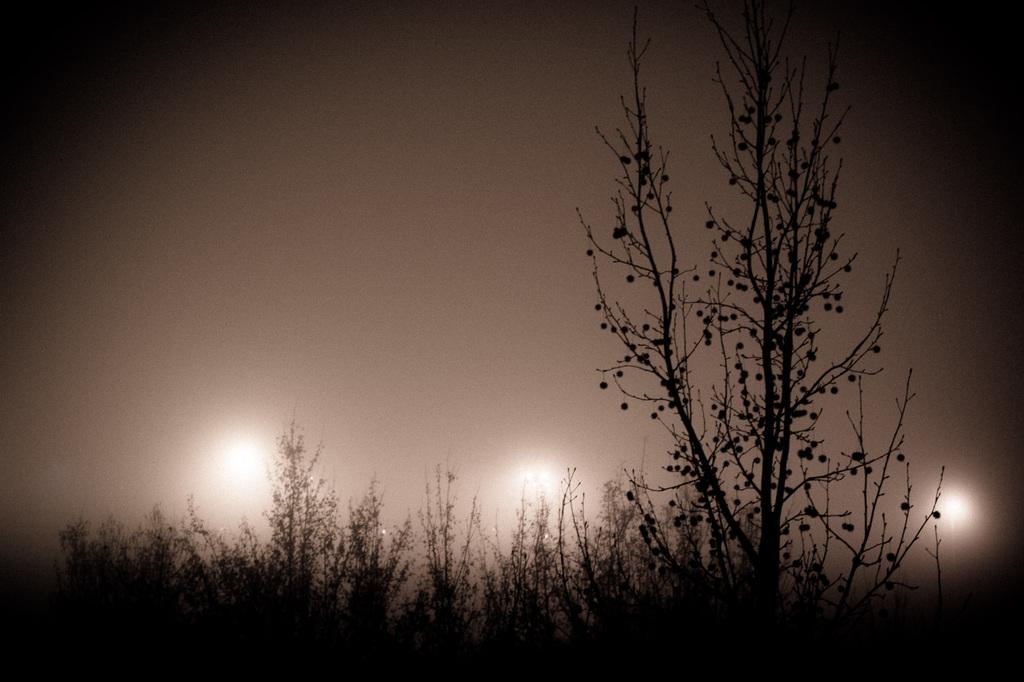What type of vegetation can be seen in the image? There are plants and trees in the image. Are there any artificial light sources visible in the image? Yes, there are lights in the image. What part of the natural environment is visible in the image? The sky is visible in the image. What type of hole can be seen in the image? There is no hole present in the image. Can you see any arms or guns in the image? There are no arms or guns present in the image. 